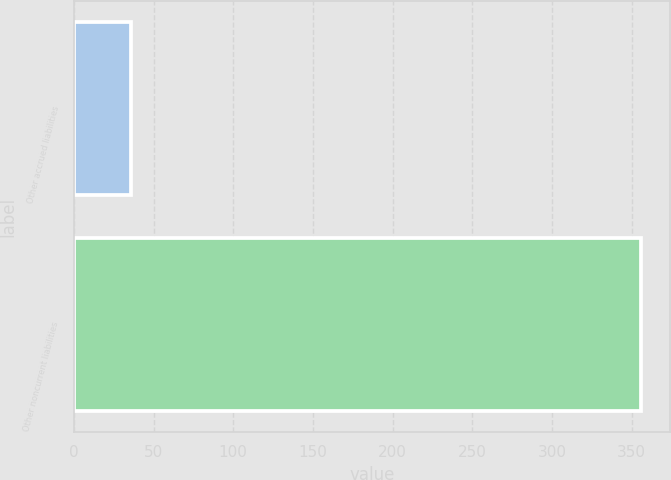Convert chart to OTSL. <chart><loc_0><loc_0><loc_500><loc_500><bar_chart><fcel>Other accrued liabilities<fcel>Other noncurrent liabilities<nl><fcel>36.1<fcel>356.1<nl></chart> 